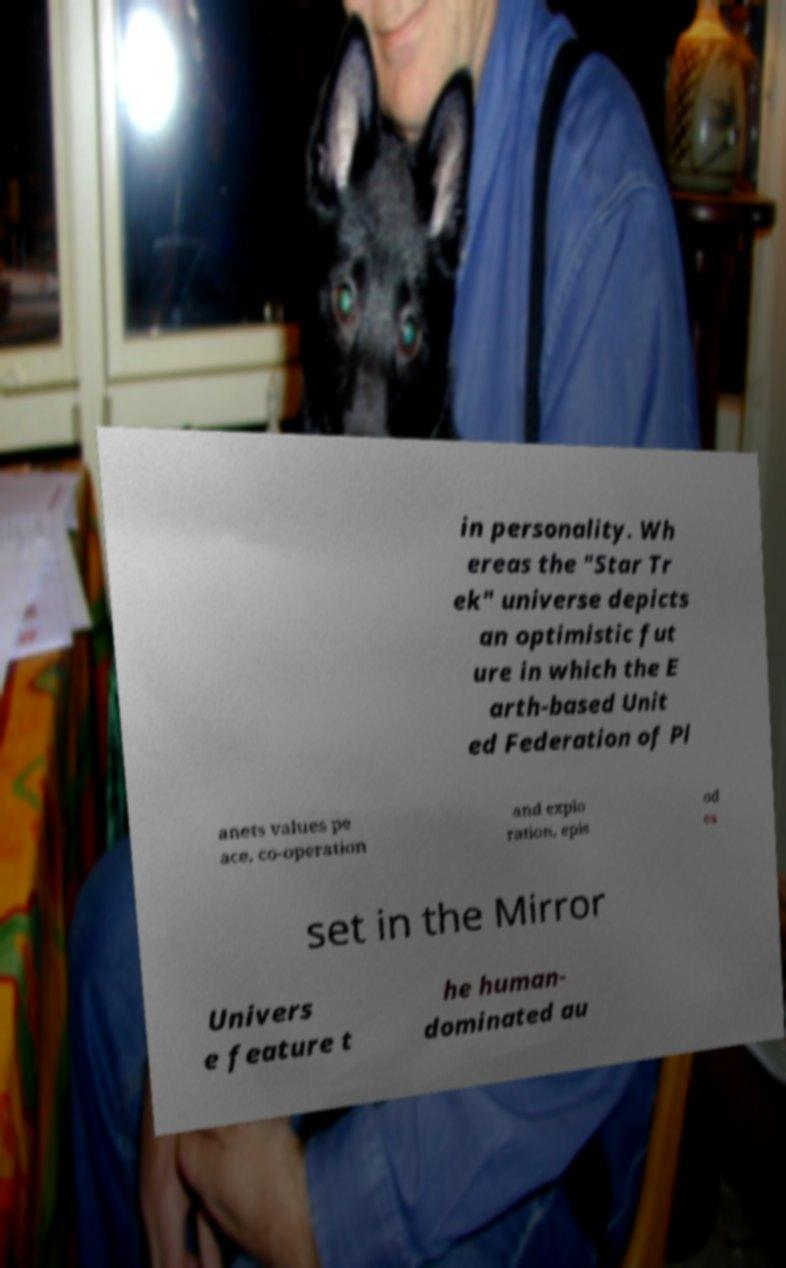Can you read and provide the text displayed in the image?This photo seems to have some interesting text. Can you extract and type it out for me? in personality. Wh ereas the "Star Tr ek" universe depicts an optimistic fut ure in which the E arth-based Unit ed Federation of Pl anets values pe ace, co-operation and explo ration, epis od es set in the Mirror Univers e feature t he human- dominated au 